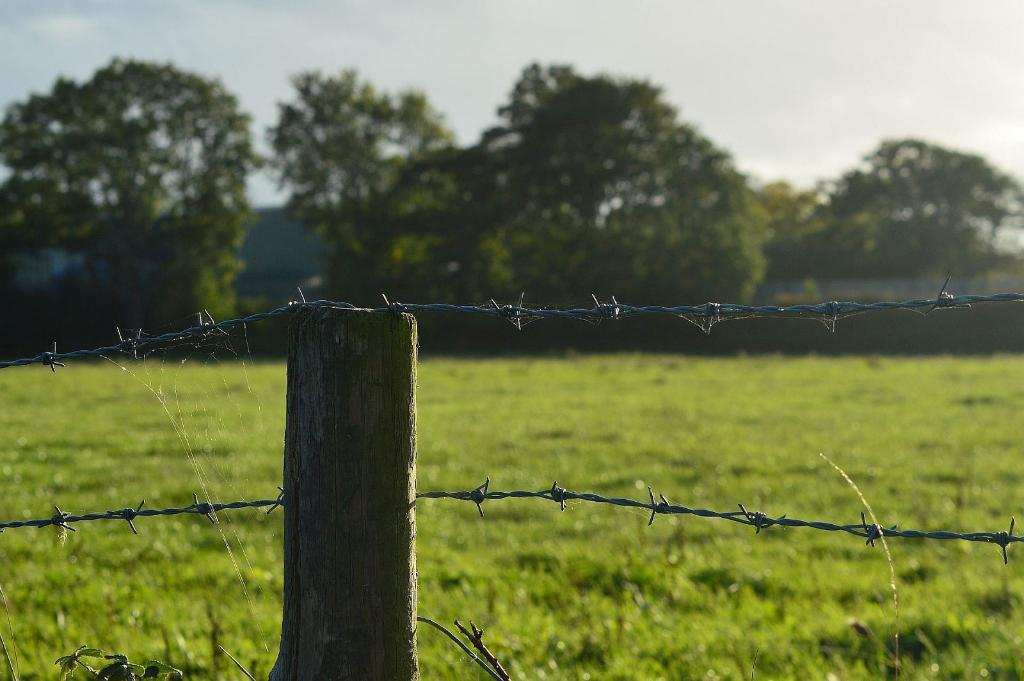What type of vegetation can be seen in the image? There are trees in the image. What is the color of the grass in the image? There is green grass in the image. What type of barrier is present in the image? There is fencing in the image. What is visible in the background of the image? The sky is visible in the image. What colors can be seen in the sky? The sky has a white and blue color. What type of quartz can be seen in the image? There is no quartz present in the image. How does the cord connect the trees in the image? There is no cord connecting the trees in the image; it is a natural scene with trees, grass, and fencing. 